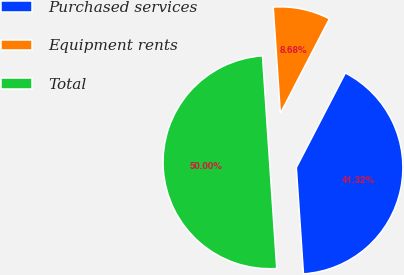Convert chart to OTSL. <chart><loc_0><loc_0><loc_500><loc_500><pie_chart><fcel>Purchased services<fcel>Equipment rents<fcel>Total<nl><fcel>41.32%<fcel>8.68%<fcel>50.0%<nl></chart> 